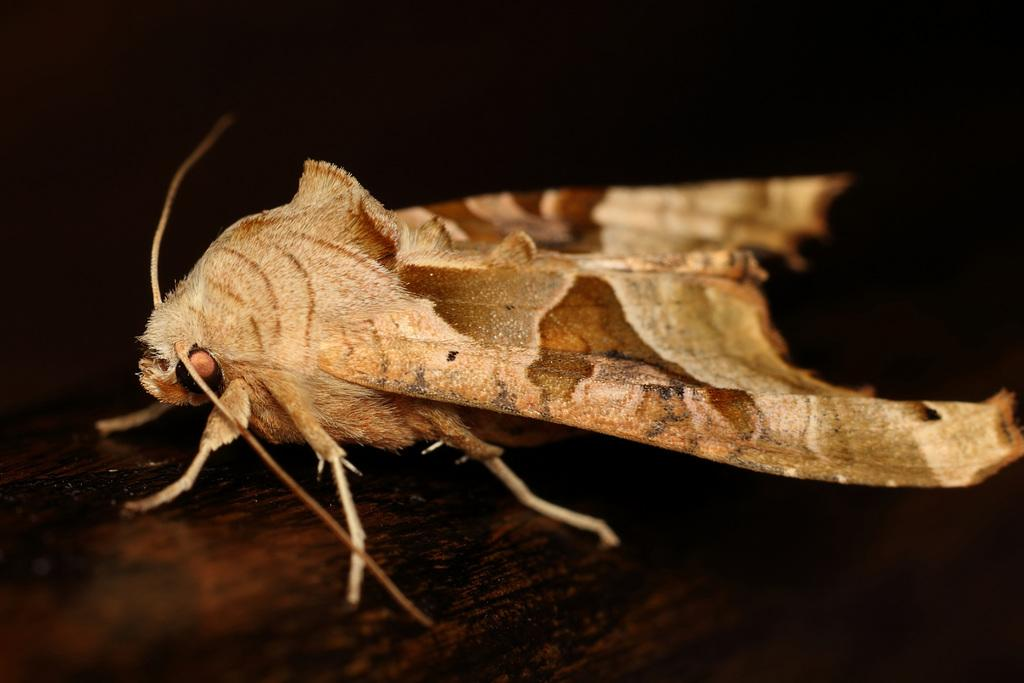What is the main subject of the image? There is an insect in the image. Where is the insect located in the image? The insect is in the center of the image. What color is the insect? The insect is brown in color. What type of oven is visible in the image? There is no oven present in the image; it features an insect. What is the thing that the insect is touching in the image? The insect is not touching anything in the image; it is simply located in the center of the image. 